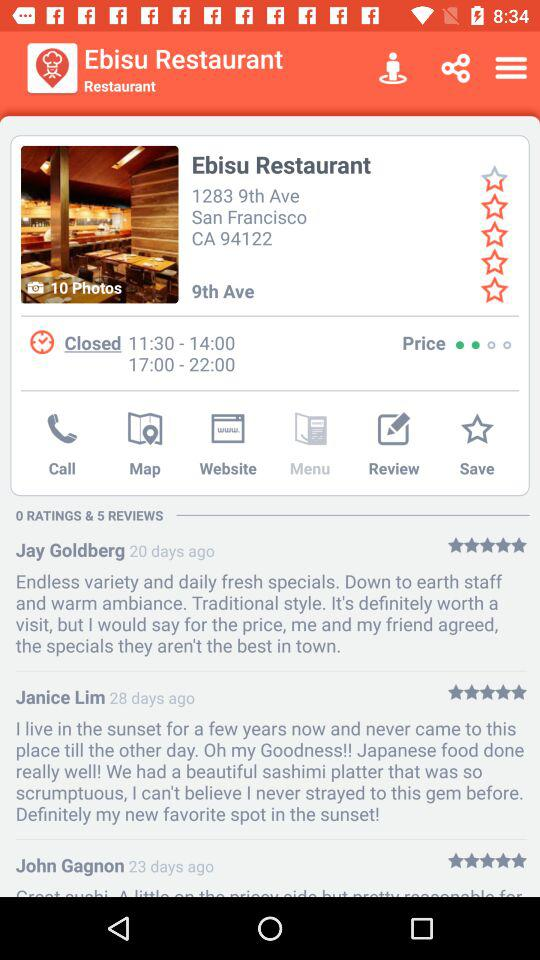What are the hours of the "Ebisu Restaurant"? The hours of the "Ebisu Restaurant" are from 11:30 to 14:00 and from 17:00 to 22:00. 